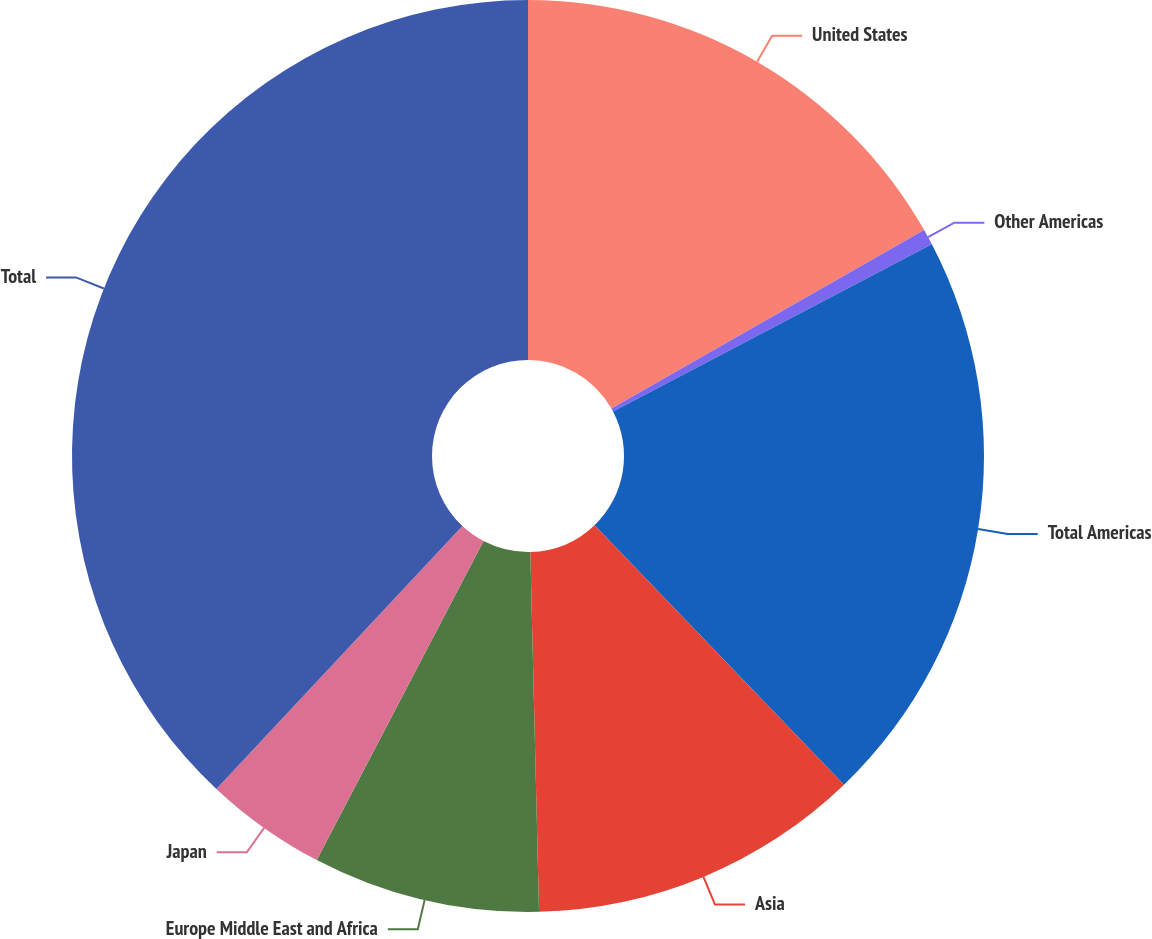Convert chart. <chart><loc_0><loc_0><loc_500><loc_500><pie_chart><fcel>United States<fcel>Other Americas<fcel>Total Americas<fcel>Asia<fcel>Europe Middle East and Africa<fcel>Japan<fcel>Total<nl><fcel>16.75%<fcel>0.56%<fcel>20.5%<fcel>11.8%<fcel>8.05%<fcel>4.31%<fcel>38.02%<nl></chart> 